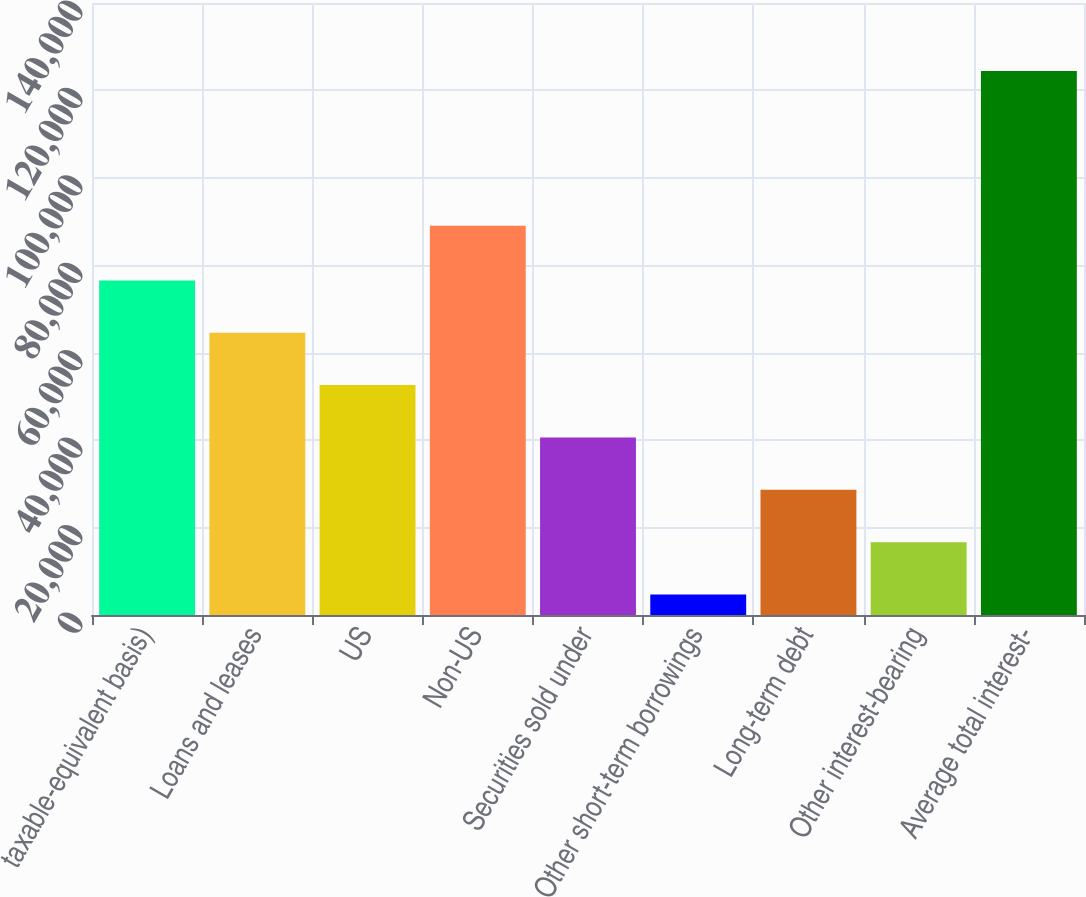Convert chart to OTSL. <chart><loc_0><loc_0><loc_500><loc_500><bar_chart><fcel>taxable-equivalent basis)<fcel>Loans and leases<fcel>US<fcel>Non-US<fcel>Securities sold under<fcel>Other short-term borrowings<fcel>Long-term debt<fcel>Other interest-bearing<fcel>Average total interest-<nl><fcel>76543.4<fcel>64565.5<fcel>52587.6<fcel>89059<fcel>40609.7<fcel>4676<fcel>28631.8<fcel>16653.9<fcel>124455<nl></chart> 